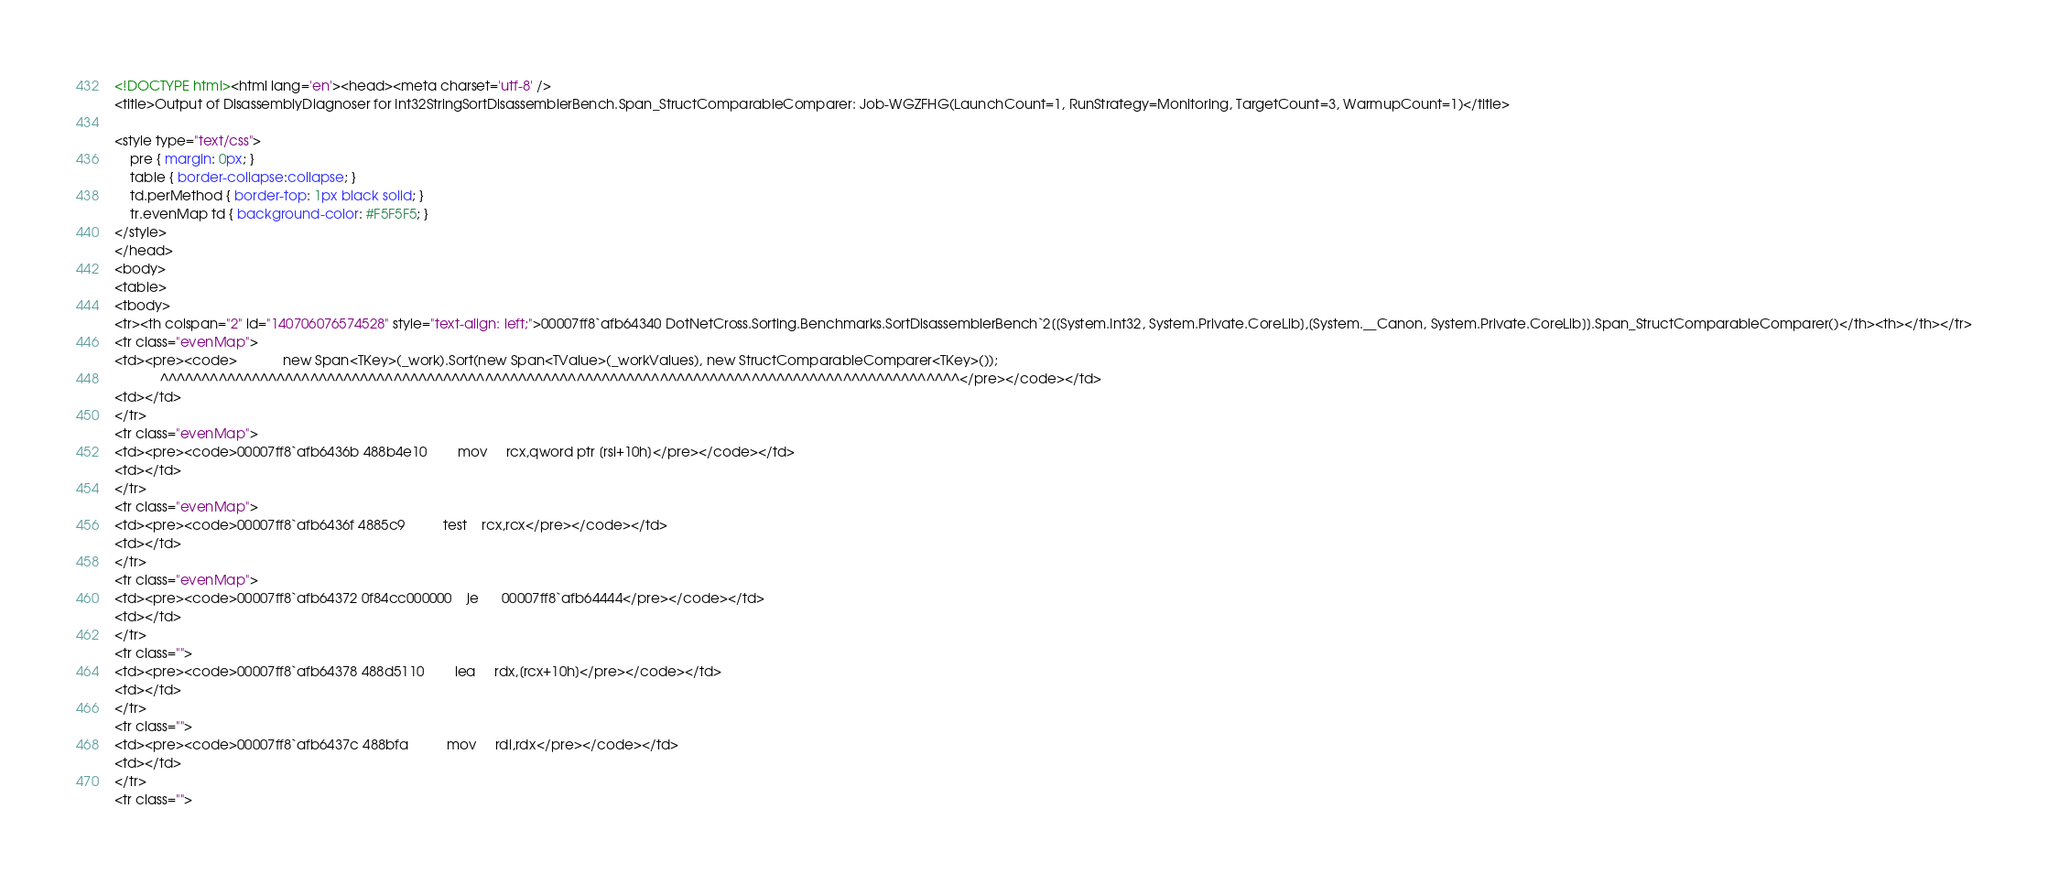Convert code to text. <code><loc_0><loc_0><loc_500><loc_500><_HTML_><!DOCTYPE html><html lang='en'><head><meta charset='utf-8' />
<title>Output of DisassemblyDiagnoser for Int32StringSortDisassemblerBench.Span_StructComparableComparer: Job-WGZFHG(LaunchCount=1, RunStrategy=Monitoring, TargetCount=3, WarmupCount=1)</title>

<style type="text/css">
    pre { margin: 0px; }
    table { border-collapse:collapse; }
    td.perMethod { border-top: 1px black solid; }
    tr.evenMap td { background-color: #F5F5F5; }  
</style>
</head>
<body>
<table>
<tbody>
<tr><th colspan="2" id="140706076574528" style="text-align: left;">00007ff8`afb64340 DotNetCross.Sorting.Benchmarks.SortDisassemblerBench`2[[System.Int32, System.Private.CoreLib],[System.__Canon, System.Private.CoreLib]].Span_StructComparableComparer()</th><th></th></tr>
<tr class="evenMap">
<td><pre><code>            new Span<TKey>(_work).Sort(new Span<TValue>(_workValues), new StructComparableComparer<TKey>());
            ^^^^^^^^^^^^^^^^^^^^^^^^^^^^^^^^^^^^^^^^^^^^^^^^^^^^^^^^^^^^^^^^^^^^^^^^^^^^^^^^^^^^^^^^^^^^^^^^</pre></code></td>
<td></td>
</tr>
<tr class="evenMap">
<td><pre><code>00007ff8`afb6436b 488b4e10        mov     rcx,qword ptr [rsi+10h]</pre></code></td>
<td></td>
</tr>
<tr class="evenMap">
<td><pre><code>00007ff8`afb6436f 4885c9          test    rcx,rcx</pre></code></td>
<td></td>
</tr>
<tr class="evenMap">
<td><pre><code>00007ff8`afb64372 0f84cc000000    je      00007ff8`afb64444</pre></code></td>
<td></td>
</tr>
<tr class="">
<td><pre><code>00007ff8`afb64378 488d5110        lea     rdx,[rcx+10h]</pre></code></td>
<td></td>
</tr>
<tr class="">
<td><pre><code>00007ff8`afb6437c 488bfa          mov     rdi,rdx</pre></code></td>
<td></td>
</tr>
<tr class=""></code> 